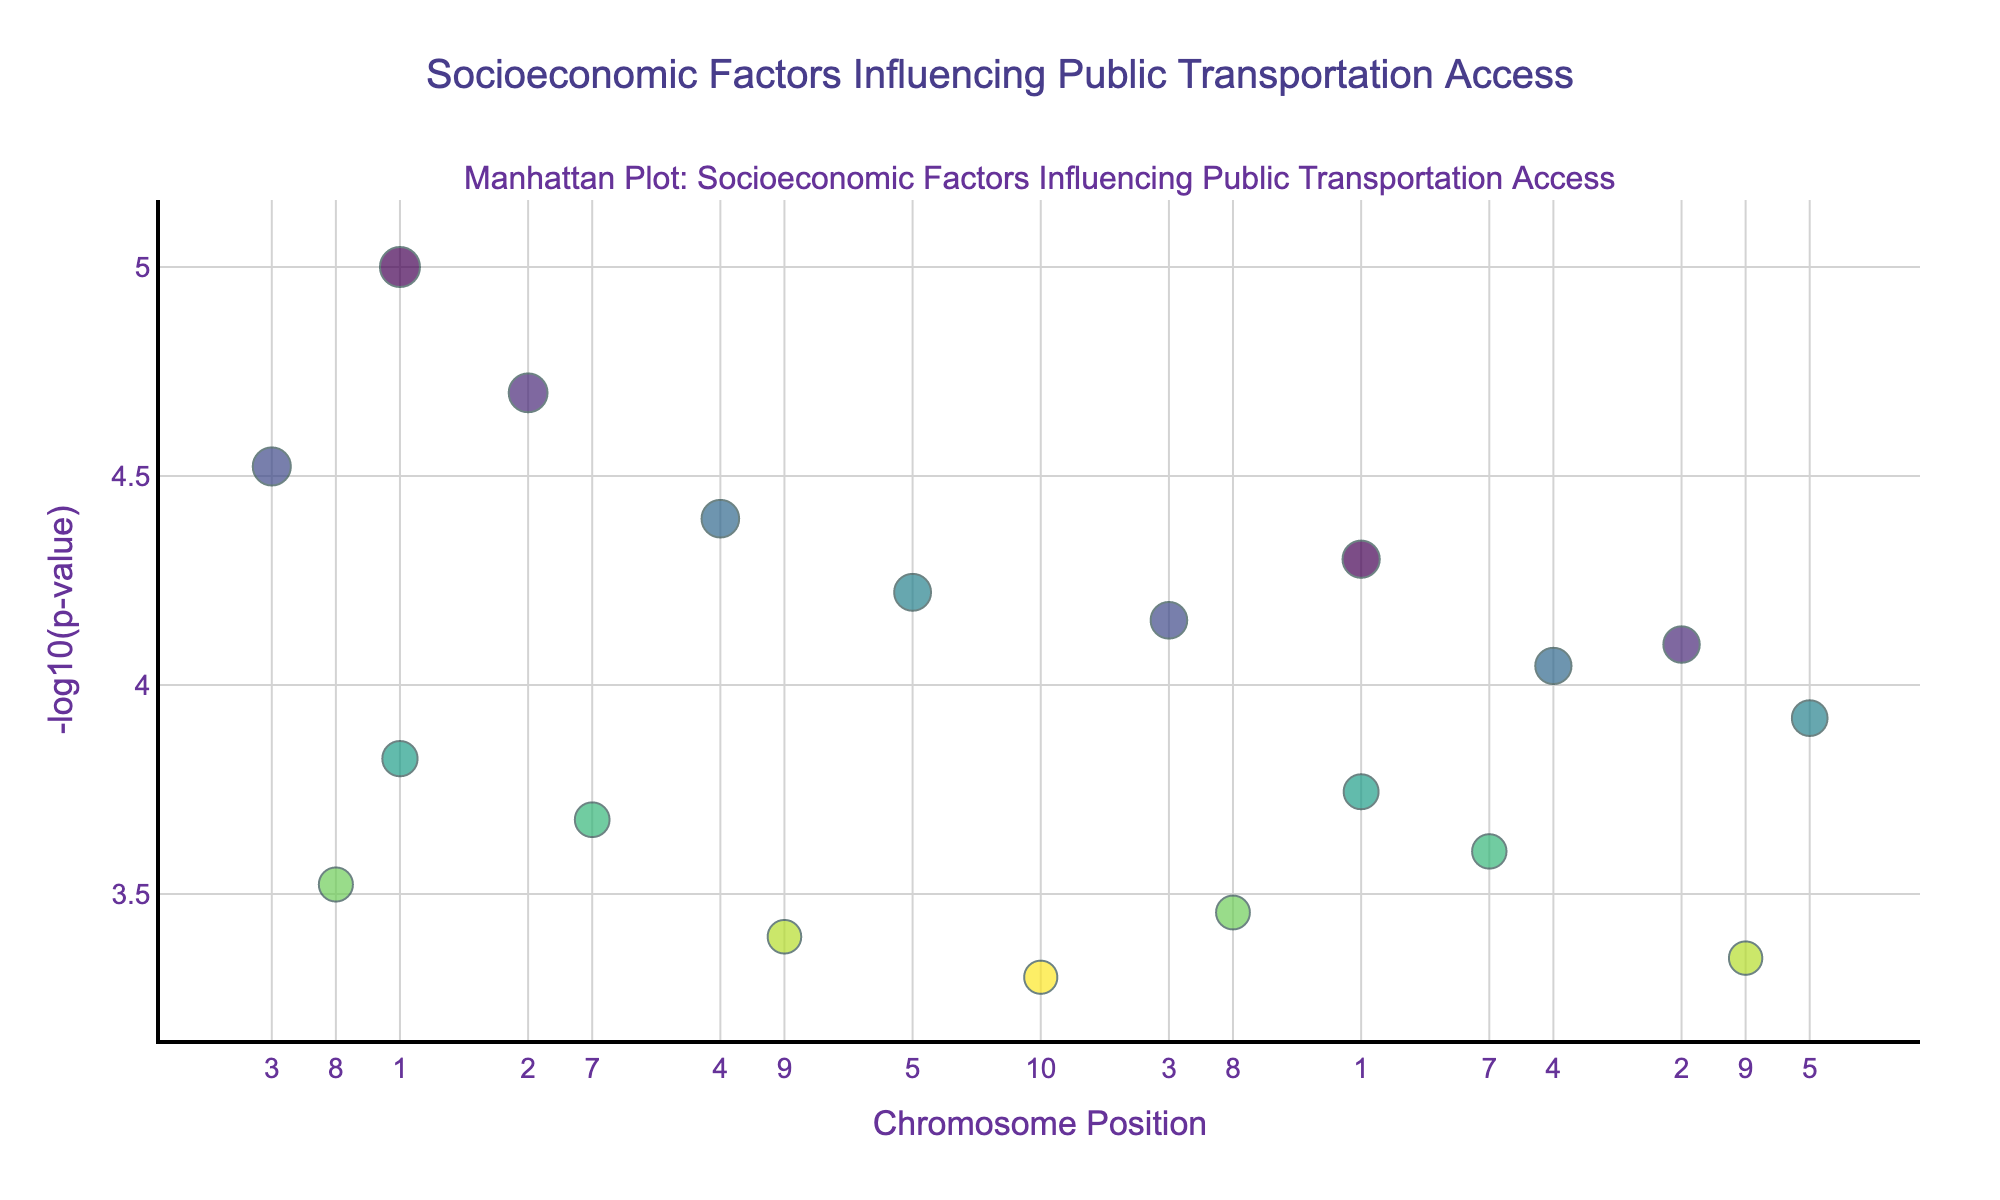What's the title of the figure? The title of the figure is typically displayed at the top of the plot. In this case, it should be "Socioeconomic Factors Influencing Public Transportation Access."
Answer: Socioeconomic Factors Influencing Public Transportation Access What does the y-axis represent? From the data and the typical structure of a Manhattan Plot, the y-axis represents "-log10(p-value)," which indicates the statistical significance of each socioeconomic factor.
Answer: -log10(p-value) Which factor has the most significant p-value? The most significant p-value corresponds to the highest -log10(p-value). By examining the y-axis, we see that Income level has the highest -log10(p-value) at chromosome 1, position 1000000.
Answer: Income level What chromosome has the highest number of data points displayed? Count the number of data points for each chromosome from the figure: Chromosome 1, Chromosome 2, and Chromosome 3 each have 2 data points, while the others have 1 data point each. Therefore, Chromosome 1 has the highest number of data points displayed.
Answer: Chromosome 1 Which factors are plotted at position 900000 and 2000000? By examining the x-axis, position 900000 corresponds to Language proficiency (Chromosome 8) and position 2000000 corresponds to Political representation (Chromosome 10).
Answer: Language proficiency and Political representation What is the approximately smallest size of the markers in the plot and which factor does it represent? Marker size is adjusted based on the significance (-log10(p-value)), representing Immigration status. The marker at position 3200000 on Chromosome 5 (Immigrant status) appears to be the smallest, which is consistent with its p-value of 0.00012.
Answer: Immigrant status How is the color of the markers determined in this plot? The color of the markers is based on the chromosome number, as indicated by the color scale 'Viridis.' Each chromosome has a unique color.
Answer: Chromosome number Which factor at chromosome 4 has a higher -log10(p-value), Racial demographics or Housing density? Look at the y-values for Chromosome 4. Racial demographics and Housing density are at y-values -log10(0.00004) and -log10(0.00009), respectively. Since -log10(0.00004) is higher, Racial demographics has a higher -log10(p-value).
Answer: Racial demographics For Chromosome 6, compare the significance of Union membership and Work shift patterns? Examine the -log10(p-value) of both factors. Union membership's -log10(p-value) is higher than that of Work shift patterns, indicating a more significant factor in access to public transportation.
Answer: Union membership What is the y-axis value for a p-value of 0.00045? Calculate -log10(0.00045) to find the y-axis value. -log10(0.00045) ≈ 3.35. So, the y-axis value is approximately 3.35.
Answer: 3.35 